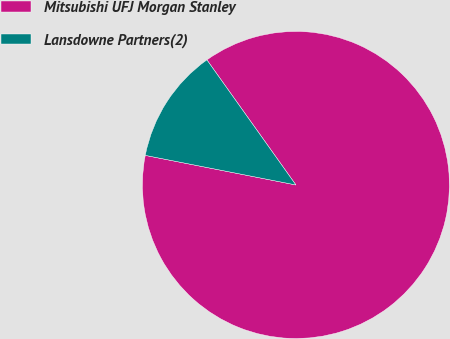Convert chart. <chart><loc_0><loc_0><loc_500><loc_500><pie_chart><fcel>Mitsubishi UFJ Morgan Stanley<fcel>Lansdowne Partners(2)<nl><fcel>87.93%<fcel>12.07%<nl></chart> 